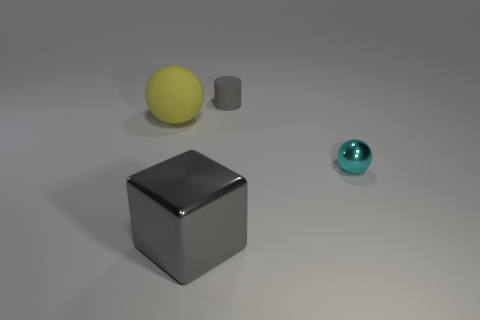Can you guess the materials of the objects? Based on the reflections and surface textures, the sphere appears to be made of a matte material like rubber, the tiny cylinder looks metallic, the large cube seems to have a reflective metal surface, and the smaller sphere has a translucent appearance, perhaps glass or a polished semi-precious stone. 